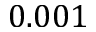<formula> <loc_0><loc_0><loc_500><loc_500>0 . 0 0 1</formula> 